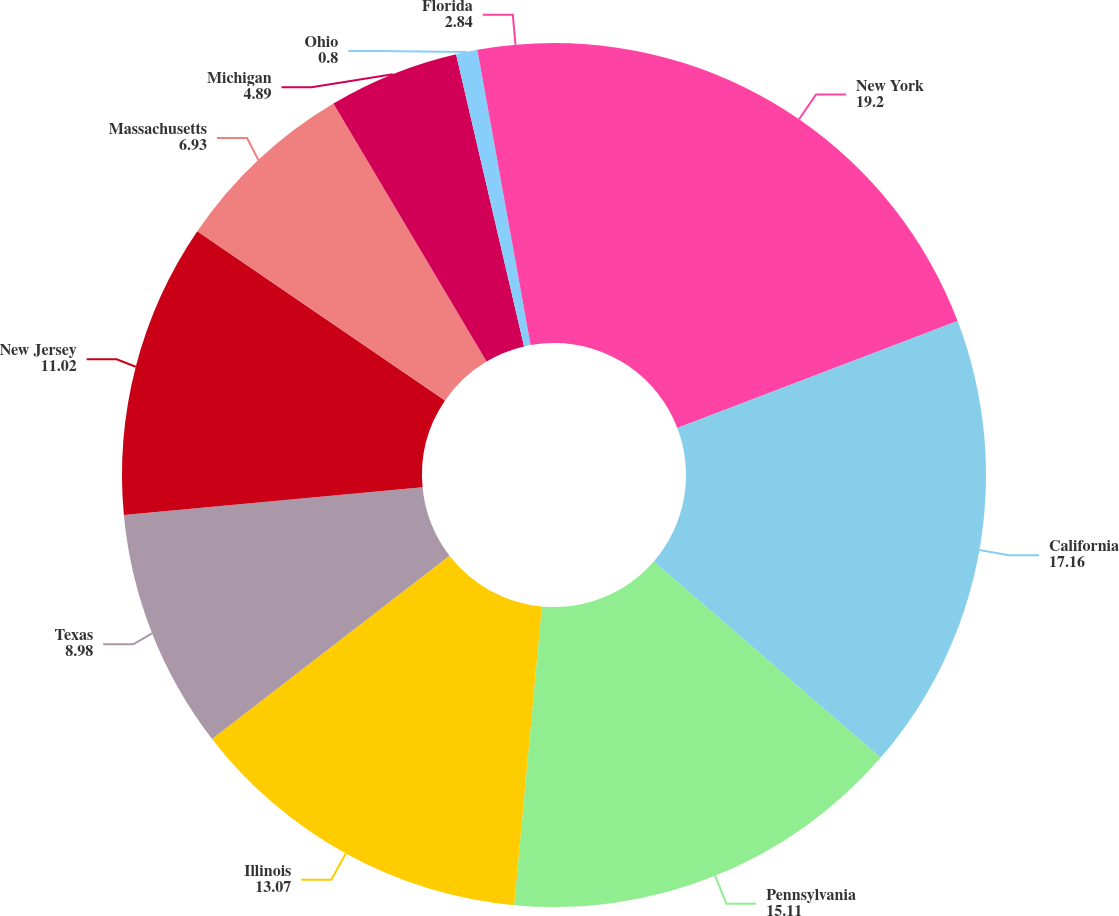Convert chart to OTSL. <chart><loc_0><loc_0><loc_500><loc_500><pie_chart><fcel>New York<fcel>California<fcel>Pennsylvania<fcel>Illinois<fcel>Texas<fcel>New Jersey<fcel>Massachusetts<fcel>Michigan<fcel>Ohio<fcel>Florida<nl><fcel>19.2%<fcel>17.16%<fcel>15.11%<fcel>13.07%<fcel>8.98%<fcel>11.02%<fcel>6.93%<fcel>4.89%<fcel>0.8%<fcel>2.84%<nl></chart> 